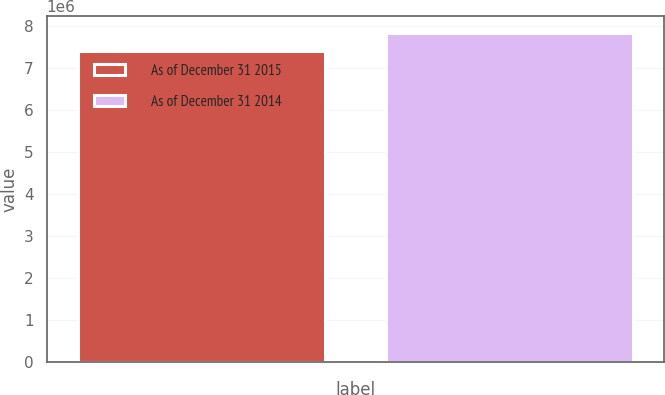<chart> <loc_0><loc_0><loc_500><loc_500><bar_chart><fcel>As of December 31 2015<fcel>As of December 31 2014<nl><fcel>7.40322e+06<fcel>7.84112e+06<nl></chart> 